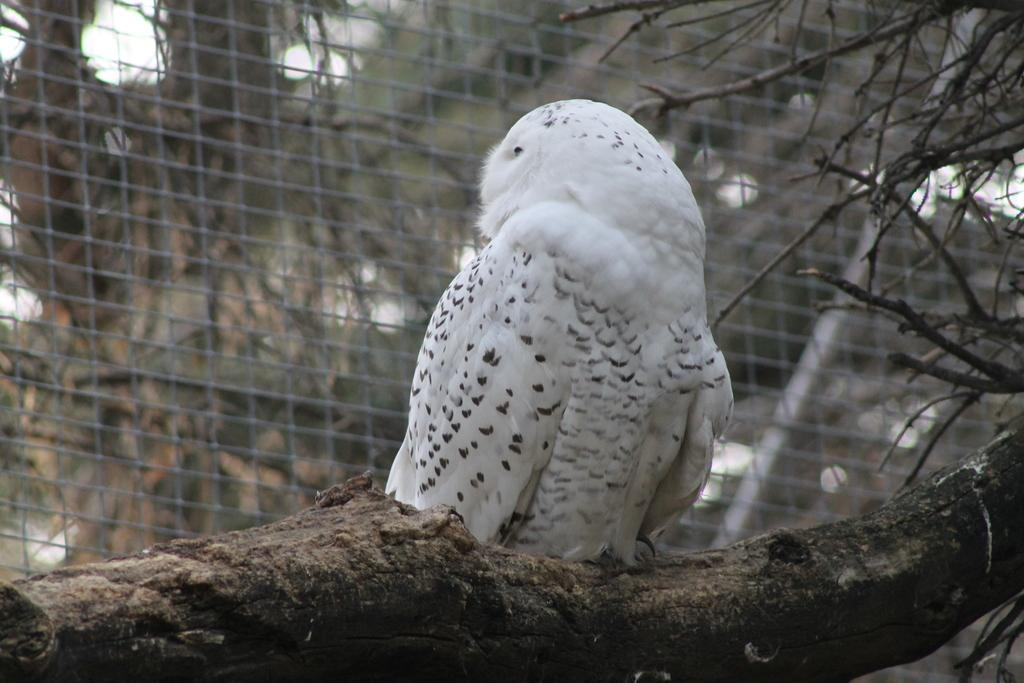What type of animal is in the image? There is a bird in the image. What surface is the bird on? The bird is on wood. What is behind the wood in the image? The wood is in front of a mesh. What is the bird's preferred route to the amusement park in the image? There is no amusement park or route mentioned in the image; it only features a bird on wood in front of a mesh. 